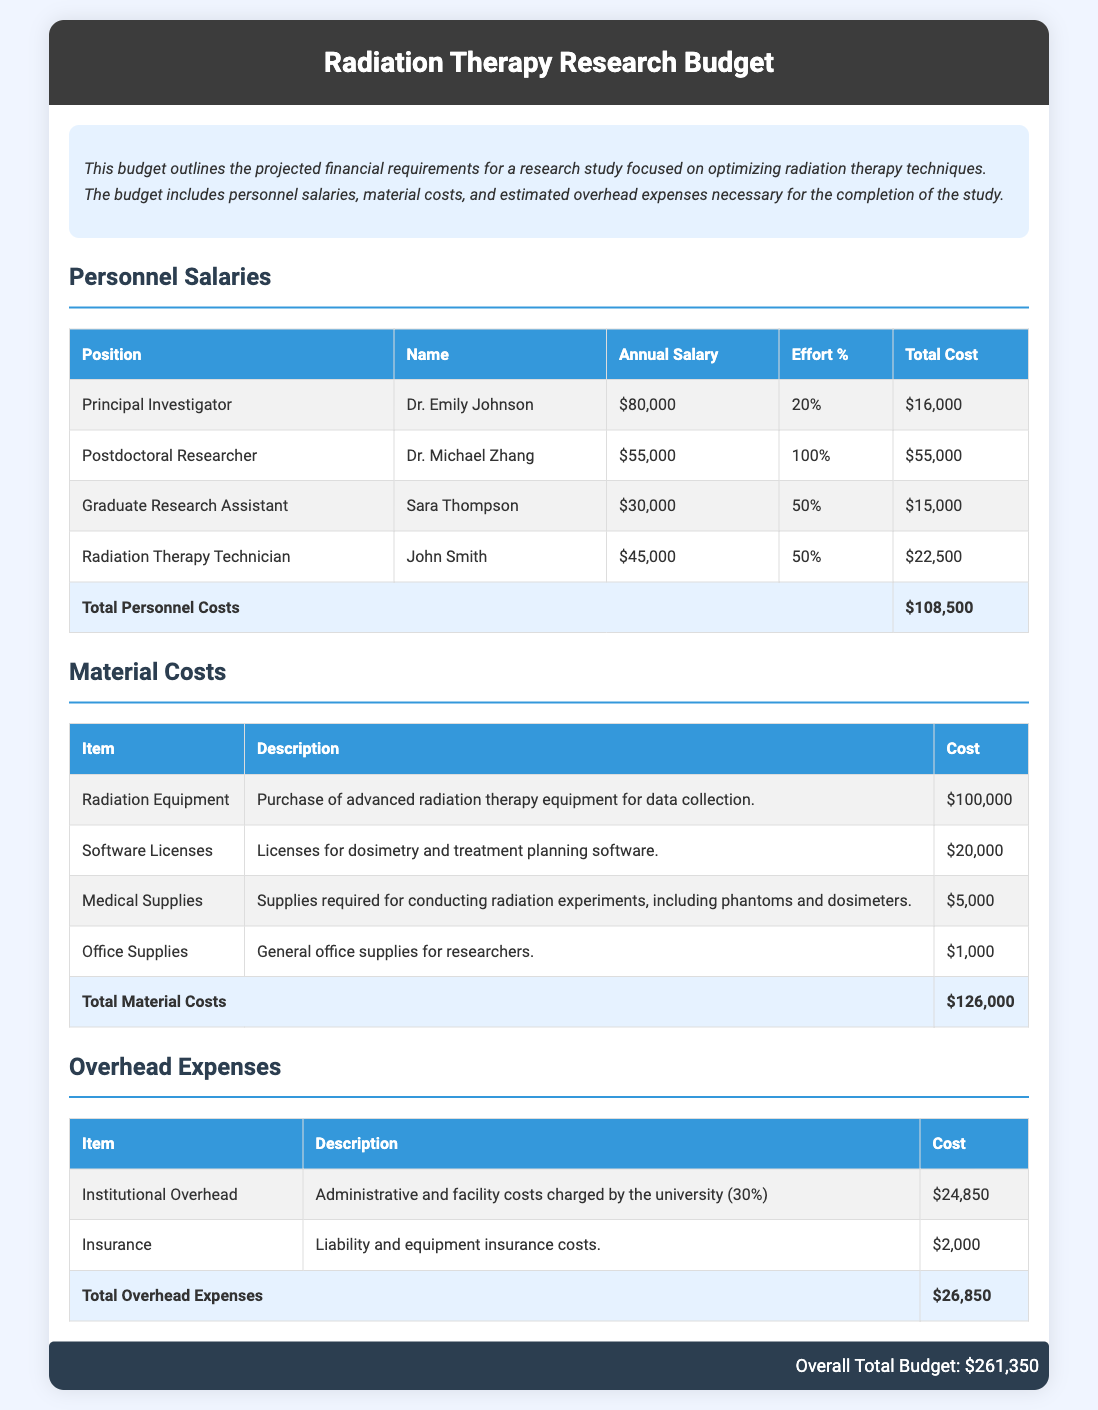What is the total personnel cost? The total personnel cost is the sum of all personnel salaries listed in the document, which is $108,500.
Answer: $108,500 Who is the Principal Investigator? The Principal Investigator is the primary researcher responsible for the study, named Dr. Emily Johnson.
Answer: Dr. Emily Johnson What percentage effort does the Postdoctoral Researcher contribute? The document states that the Postdoctoral Researcher contributes 100% effort to the project.
Answer: 100% What is the cost of Radiation Equipment? The document specifies that the cost of Radiation Equipment is $100,000 for the study.
Answer: $100,000 What are the total overhead expenses? The total overhead expenses mentioned in the document amount to $26,850.
Answer: $26,850 What type of insurance is included in the overhead expenses? The document indicates that liability and equipment insurance costs are part of the overhead expenses.
Answer: Liability and equipment What is the overall total budget for the study? The overall total budget is calculated by adding all costs together, which comes to $261,350.
Answer: $261,350 How much are the software licenses? The cost listed for software licenses in the document is $20,000.
Answer: $20,000 What is the total cost for medical supplies? The total cost specified for medical supplies in the budget is $5,000.
Answer: $5,000 